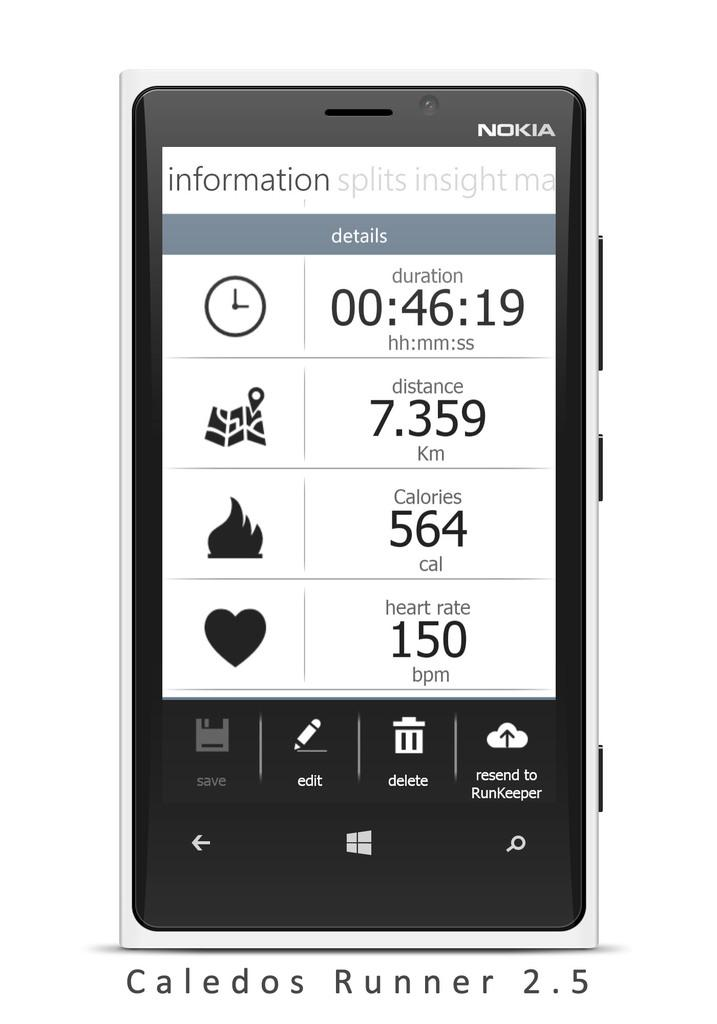What type of mobile is visible in the image? There is a Nokia mobile in the image. What can be found at the bottom of the image? There is text written at the bottom of the image. What color is the background of the image? The background of the image is white. Did the earthquake cause any damage to the mobile in the image? There is no mention of an earthquake in the provided facts, and no damage is visible on the mobile in the image. 